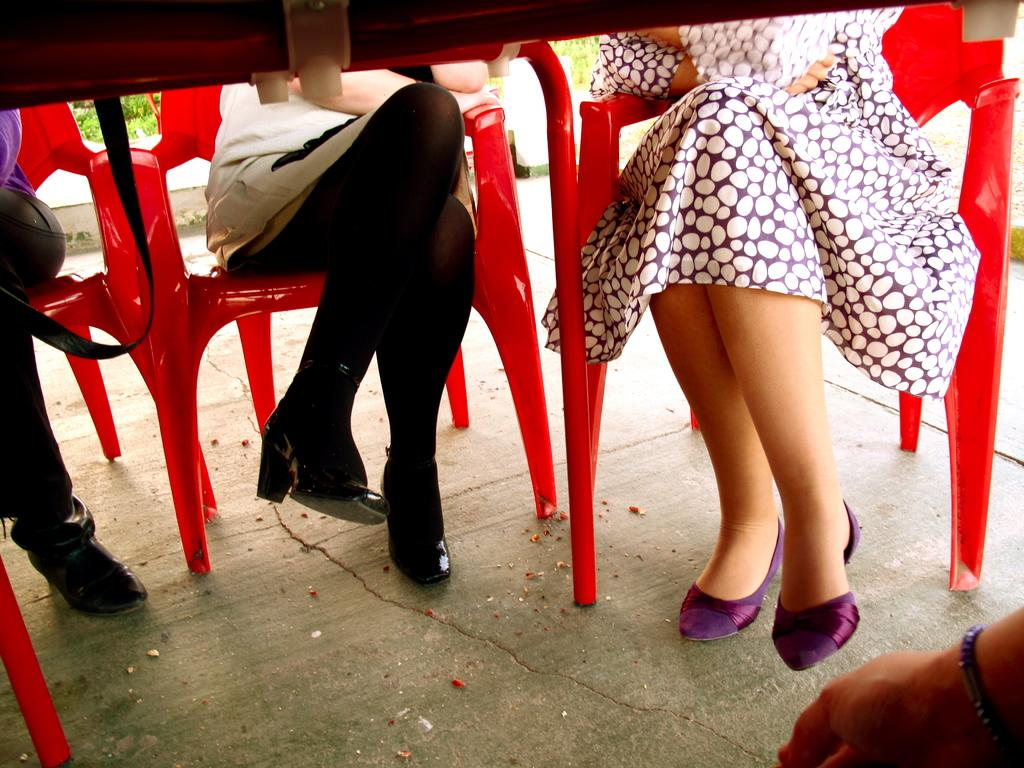Who or what is present in the image? There are people in the image. What are the people sitting on? The people are sitting on red chairs. What else can be seen in the image besides the people and chairs? There are leaves visible in the image. What type of machine is being used by the people in the image? There is no machine present in the image; the people are simply sitting on red chairs. 